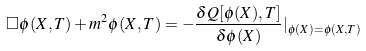<formula> <loc_0><loc_0><loc_500><loc_500>\Box \phi ( X , T ) + m ^ { 2 } \phi ( X , T ) = - \frac { \delta Q [ \phi ( X ) , T ] } { \delta \phi ( X ) } | _ { \phi ( X ) = \phi ( X , T ) }</formula> 